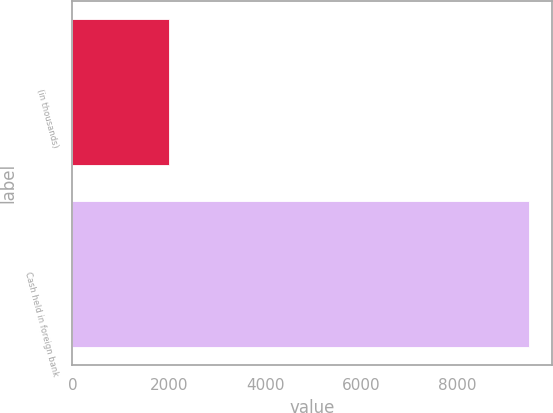Convert chart. <chart><loc_0><loc_0><loc_500><loc_500><bar_chart><fcel>(in thousands)<fcel>Cash held in foreign bank<nl><fcel>2006<fcel>9487<nl></chart> 